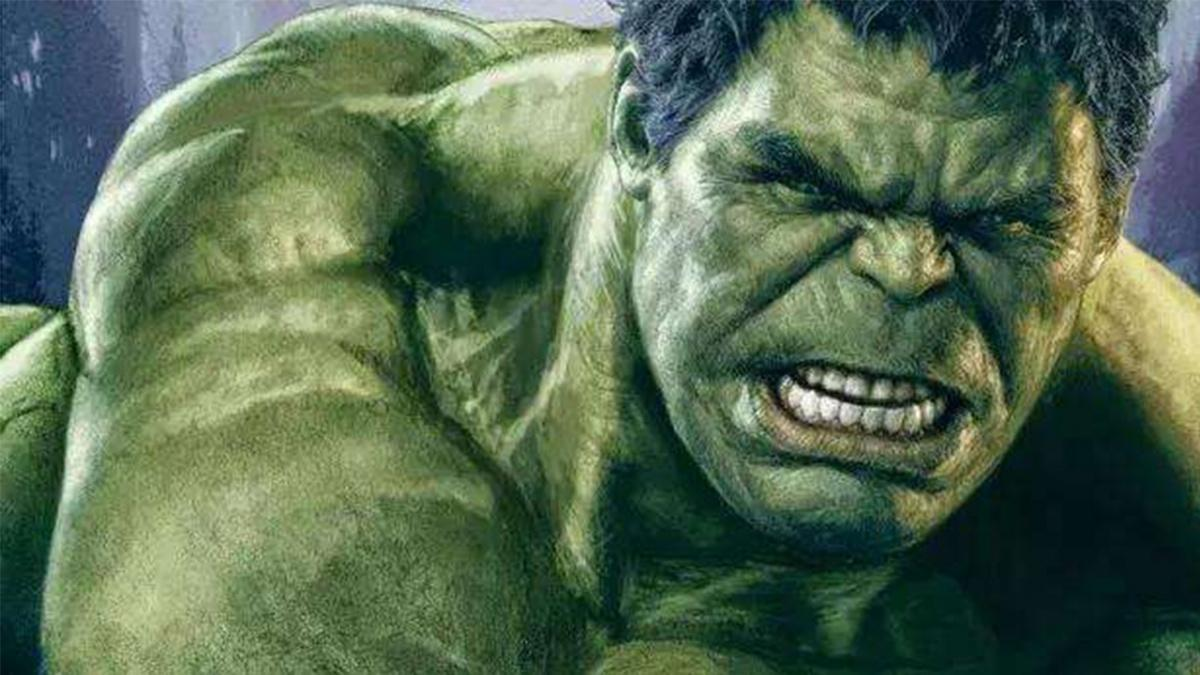这是哪部影视作品中的人物 这张图片中的人物是绿巨人浩克（Hulk），他是漫威漫画中的超级英雄角色，出现在许多漫威电影宇宙（MCU）的电影中，包括《复仇者联盟》系列和《无敌浩克》等。 